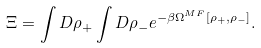Convert formula to latex. <formula><loc_0><loc_0><loc_500><loc_500>\Xi = \int D \rho _ { + } \int D \rho _ { - } e ^ { - \beta \Omega ^ { M F } [ \rho _ { + } , \rho _ { - } ] } .</formula> 